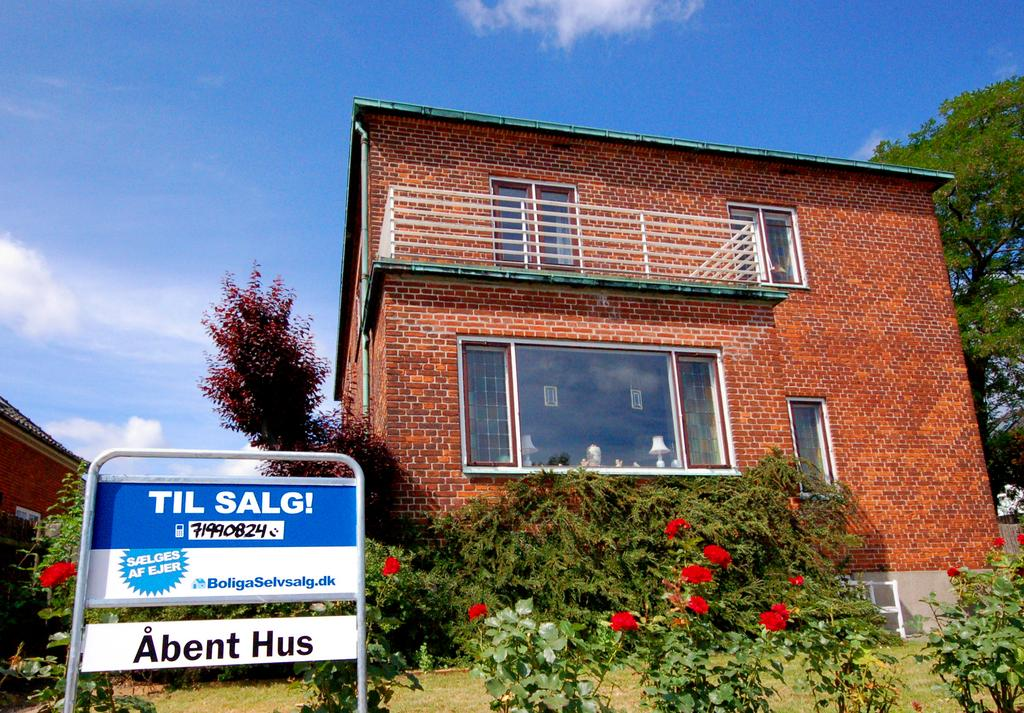What type of structures can be seen in the image? There are buildings in the image. What natural elements are present in the image? There are trees and flower plants in the image. What man-made object with writing can be seen in the image? There is a board with writing in the image. What is visible in the background of the image? The sky is visible in the background of the image. What type of bean is being used to fix the suit in the image? There is no bean or suit present in the image. What tool is being used to tighten the wrench in the image? There is no wrench or tool present in the image. 